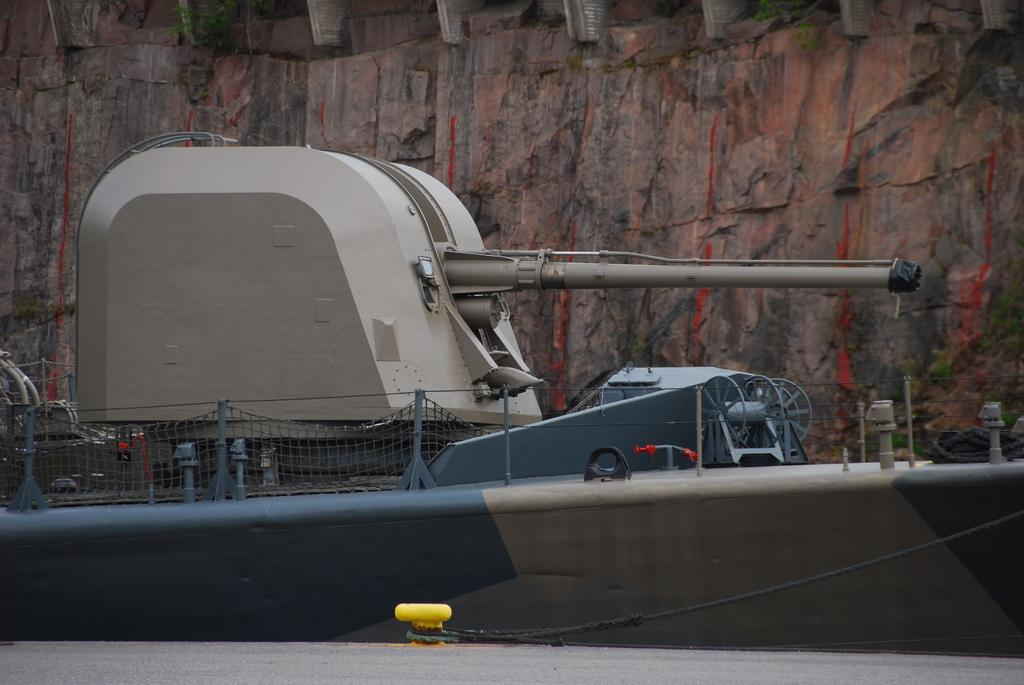What is located at the bottom of the image? There is a road at the bottom of the image. What object can be seen in the foreground of the image? There appears to be a cannon in the foreground of the image. What type of natural feature is visible in the background of the image? There is a mountain in the background of the image. What substance is being stored in the quiver in the image? There is no quiver present in the image, so it is not possible to answer that question. 